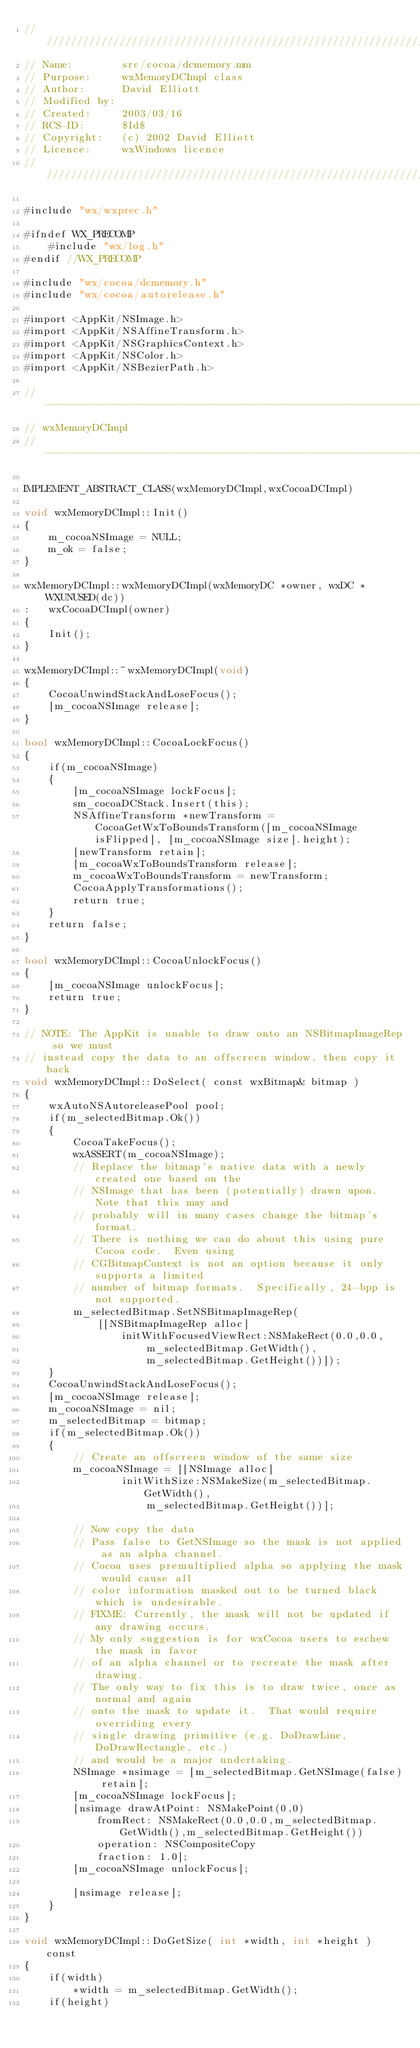Convert code to text. <code><loc_0><loc_0><loc_500><loc_500><_ObjectiveC_>/////////////////////////////////////////////////////////////////////////////
// Name:        src/cocoa/dcmemory.mm
// Purpose:     wxMemoryDCImpl class
// Author:      David Elliott
// Modified by:
// Created:     2003/03/16
// RCS-ID:      $Id$
// Copyright:   (c) 2002 David Elliott
// Licence:     wxWindows licence
/////////////////////////////////////////////////////////////////////////////

#include "wx/wxprec.h"

#ifndef WX_PRECOMP
    #include "wx/log.h"
#endif //WX_PRECOMP

#include "wx/cocoa/dcmemory.h"
#include "wx/cocoa/autorelease.h"

#import <AppKit/NSImage.h>
#import <AppKit/NSAffineTransform.h>
#import <AppKit/NSGraphicsContext.h>
#import <AppKit/NSColor.h>
#import <AppKit/NSBezierPath.h>

//-----------------------------------------------------------------------------
// wxMemoryDCImpl
//-----------------------------------------------------------------------------

IMPLEMENT_ABSTRACT_CLASS(wxMemoryDCImpl,wxCocoaDCImpl)

void wxMemoryDCImpl::Init()
{
    m_cocoaNSImage = NULL;
    m_ok = false;
}

wxMemoryDCImpl::wxMemoryDCImpl(wxMemoryDC *owner, wxDC *WXUNUSED(dc))
:   wxCocoaDCImpl(owner)
{
    Init();
}

wxMemoryDCImpl::~wxMemoryDCImpl(void)
{
    CocoaUnwindStackAndLoseFocus();
    [m_cocoaNSImage release];
}

bool wxMemoryDCImpl::CocoaLockFocus()
{
    if(m_cocoaNSImage)
    {
        [m_cocoaNSImage lockFocus];
        sm_cocoaDCStack.Insert(this);
        NSAffineTransform *newTransform = CocoaGetWxToBoundsTransform([m_cocoaNSImage isFlipped], [m_cocoaNSImage size].height);
        [newTransform retain];
        [m_cocoaWxToBoundsTransform release];
        m_cocoaWxToBoundsTransform = newTransform;
        CocoaApplyTransformations();
        return true;
    }
    return false;
}

bool wxMemoryDCImpl::CocoaUnlockFocus()
{
    [m_cocoaNSImage unlockFocus];
    return true;
}

// NOTE: The AppKit is unable to draw onto an NSBitmapImageRep so we must
// instead copy the data to an offscreen window, then copy it back
void wxMemoryDCImpl::DoSelect( const wxBitmap& bitmap )
{
    wxAutoNSAutoreleasePool pool;
    if(m_selectedBitmap.Ok())
    {
        CocoaTakeFocus();
        wxASSERT(m_cocoaNSImage);
        // Replace the bitmap's native data with a newly created one based on the
        // NSImage that has been (potentially) drawn upon.  Note that this may and
        // probably will in many cases change the bitmap's format.
        // There is nothing we can do about this using pure Cocoa code.  Even using
        // CGBitmapContext is not an option because it only supports a limited
        // number of bitmap formats.  Specifically, 24-bpp is not supported.
        m_selectedBitmap.SetNSBitmapImageRep(
            [[NSBitmapImageRep alloc]
                initWithFocusedViewRect:NSMakeRect(0.0,0.0,
                    m_selectedBitmap.GetWidth(),
                    m_selectedBitmap.GetHeight())]);
    }
    CocoaUnwindStackAndLoseFocus();
    [m_cocoaNSImage release];
    m_cocoaNSImage = nil;
    m_selectedBitmap = bitmap;
    if(m_selectedBitmap.Ok())
    {
        // Create an offscreen window of the same size
        m_cocoaNSImage = [[NSImage alloc]
                initWithSize:NSMakeSize(m_selectedBitmap.GetWidth(),
                    m_selectedBitmap.GetHeight())];

        // Now copy the data
        // Pass false to GetNSImage so the mask is not applied as an alpha channel.
        // Cocoa uses premultiplied alpha so applying the mask would cause all
        // color information masked out to be turned black which is undesirable.
        // FIXME: Currently, the mask will not be updated if any drawing occurs.
        // My only suggestion is for wxCocoa users to eschew the mask in favor
        // of an alpha channel or to recreate the mask after drawing.
        // The only way to fix this is to draw twice, once as normal and again
        // onto the mask to update it.  That would require overriding every
        // single drawing primitive (e.g. DoDrawLine, DoDrawRectangle, etc.)
        // and would be a major undertaking.
        NSImage *nsimage = [m_selectedBitmap.GetNSImage(false) retain];
        [m_cocoaNSImage lockFocus];
        [nsimage drawAtPoint: NSMakePoint(0,0)
            fromRect: NSMakeRect(0.0,0.0,m_selectedBitmap.GetWidth(),m_selectedBitmap.GetHeight())
            operation: NSCompositeCopy
            fraction: 1.0];
        [m_cocoaNSImage unlockFocus];

        [nsimage release];
    }
}

void wxMemoryDCImpl::DoGetSize( int *width, int *height ) const
{
    if(width)
        *width = m_selectedBitmap.GetWidth();
    if(height)</code> 